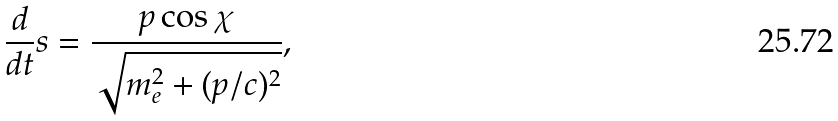Convert formula to latex. <formula><loc_0><loc_0><loc_500><loc_500>\frac { d } { d t } s = \frac { p \cos \chi } { \sqrt { m _ { e } ^ { 2 } + ( p / c ) ^ { 2 } } } ,</formula> 